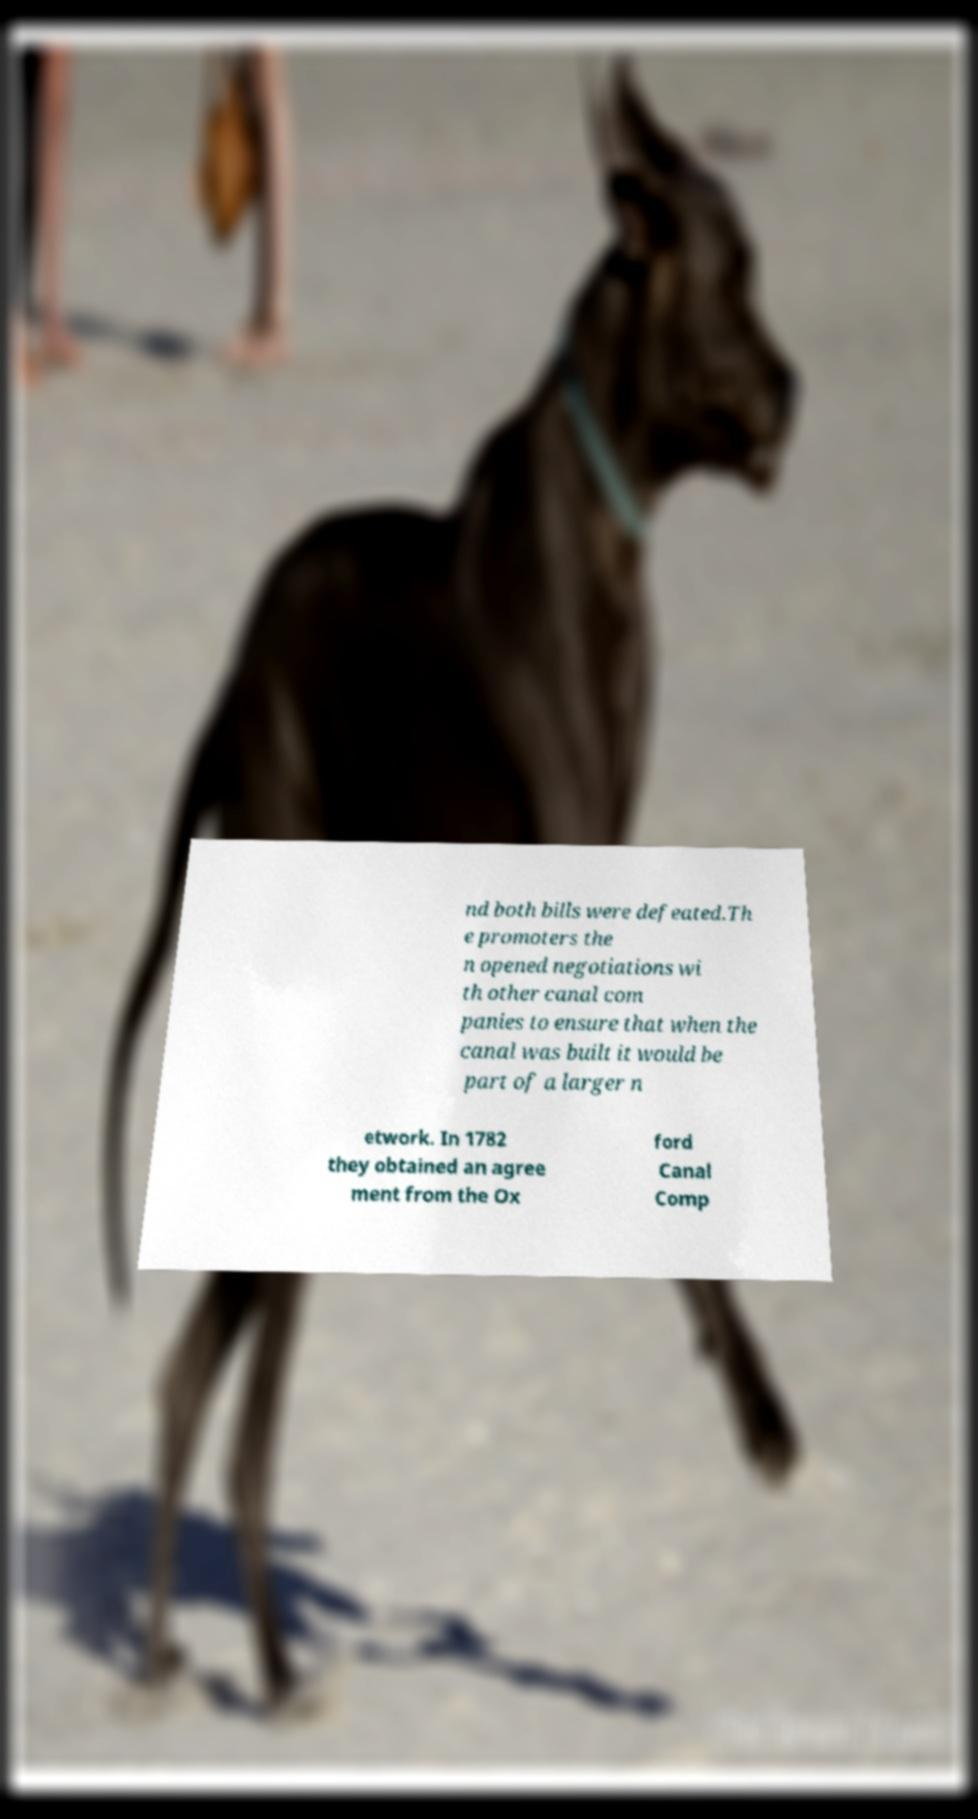I need the written content from this picture converted into text. Can you do that? nd both bills were defeated.Th e promoters the n opened negotiations wi th other canal com panies to ensure that when the canal was built it would be part of a larger n etwork. In 1782 they obtained an agree ment from the Ox ford Canal Comp 